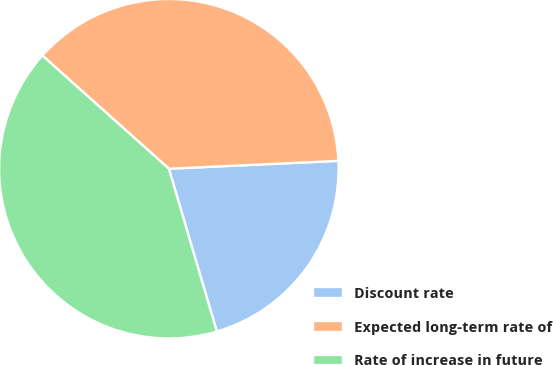<chart> <loc_0><loc_0><loc_500><loc_500><pie_chart><fcel>Discount rate<fcel>Expected long-term rate of<fcel>Rate of increase in future<nl><fcel>21.18%<fcel>37.65%<fcel>41.18%<nl></chart> 